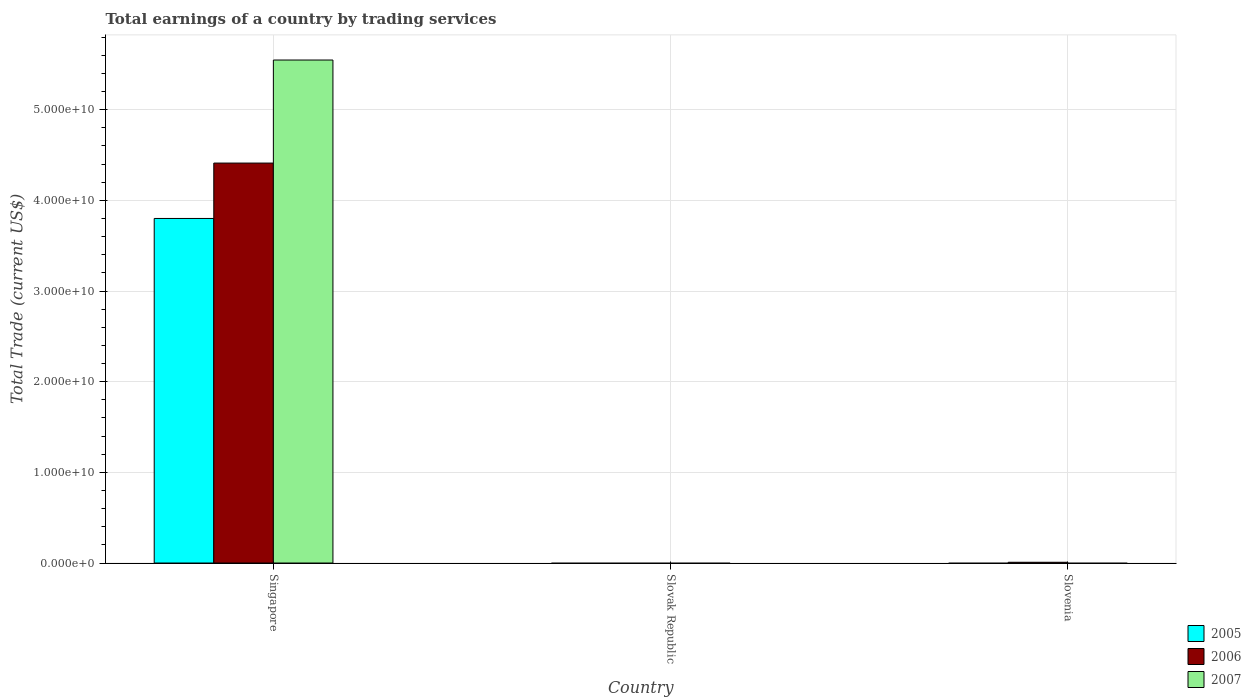Are the number of bars on each tick of the X-axis equal?
Your answer should be compact. No. How many bars are there on the 2nd tick from the left?
Give a very brief answer. 0. What is the label of the 2nd group of bars from the left?
Provide a succinct answer. Slovak Republic. What is the total earnings in 2006 in Singapore?
Your answer should be very brief. 4.41e+1. Across all countries, what is the maximum total earnings in 2006?
Provide a succinct answer. 4.41e+1. Across all countries, what is the minimum total earnings in 2005?
Your response must be concise. 0. In which country was the total earnings in 2007 maximum?
Your response must be concise. Singapore. What is the total total earnings in 2006 in the graph?
Provide a succinct answer. 4.42e+1. What is the difference between the total earnings in 2006 in Singapore and that in Slovenia?
Your answer should be compact. 4.40e+1. What is the difference between the total earnings in 2005 in Slovenia and the total earnings in 2006 in Slovak Republic?
Ensure brevity in your answer.  0. What is the average total earnings in 2006 per country?
Offer a terse response. 1.47e+1. What is the difference between the total earnings of/in 2007 and total earnings of/in 2005 in Singapore?
Provide a succinct answer. 1.75e+1. What is the ratio of the total earnings in 2006 in Singapore to that in Slovenia?
Your answer should be very brief. 526.53. What is the difference between the highest and the lowest total earnings in 2006?
Provide a short and direct response. 4.41e+1. Is it the case that in every country, the sum of the total earnings in 2007 and total earnings in 2005 is greater than the total earnings in 2006?
Keep it short and to the point. No. What is the difference between two consecutive major ticks on the Y-axis?
Your answer should be compact. 1.00e+1. Where does the legend appear in the graph?
Provide a succinct answer. Bottom right. What is the title of the graph?
Offer a very short reply. Total earnings of a country by trading services. What is the label or title of the Y-axis?
Provide a succinct answer. Total Trade (current US$). What is the Total Trade (current US$) of 2005 in Singapore?
Provide a short and direct response. 3.80e+1. What is the Total Trade (current US$) in 2006 in Singapore?
Provide a succinct answer. 4.41e+1. What is the Total Trade (current US$) of 2007 in Singapore?
Make the answer very short. 5.55e+1. What is the Total Trade (current US$) in 2005 in Slovenia?
Keep it short and to the point. 0. What is the Total Trade (current US$) in 2006 in Slovenia?
Make the answer very short. 8.38e+07. Across all countries, what is the maximum Total Trade (current US$) of 2005?
Your answer should be very brief. 3.80e+1. Across all countries, what is the maximum Total Trade (current US$) of 2006?
Your response must be concise. 4.41e+1. Across all countries, what is the maximum Total Trade (current US$) in 2007?
Make the answer very short. 5.55e+1. Across all countries, what is the minimum Total Trade (current US$) in 2005?
Provide a short and direct response. 0. Across all countries, what is the minimum Total Trade (current US$) in 2006?
Your answer should be compact. 0. Across all countries, what is the minimum Total Trade (current US$) in 2007?
Make the answer very short. 0. What is the total Total Trade (current US$) in 2005 in the graph?
Your response must be concise. 3.80e+1. What is the total Total Trade (current US$) of 2006 in the graph?
Your response must be concise. 4.42e+1. What is the total Total Trade (current US$) in 2007 in the graph?
Offer a terse response. 5.55e+1. What is the difference between the Total Trade (current US$) in 2006 in Singapore and that in Slovenia?
Your response must be concise. 4.40e+1. What is the difference between the Total Trade (current US$) of 2005 in Singapore and the Total Trade (current US$) of 2006 in Slovenia?
Your answer should be very brief. 3.79e+1. What is the average Total Trade (current US$) in 2005 per country?
Offer a terse response. 1.27e+1. What is the average Total Trade (current US$) of 2006 per country?
Provide a short and direct response. 1.47e+1. What is the average Total Trade (current US$) in 2007 per country?
Ensure brevity in your answer.  1.85e+1. What is the difference between the Total Trade (current US$) in 2005 and Total Trade (current US$) in 2006 in Singapore?
Provide a short and direct response. -6.11e+09. What is the difference between the Total Trade (current US$) of 2005 and Total Trade (current US$) of 2007 in Singapore?
Make the answer very short. -1.75e+1. What is the difference between the Total Trade (current US$) of 2006 and Total Trade (current US$) of 2007 in Singapore?
Your answer should be very brief. -1.14e+1. What is the ratio of the Total Trade (current US$) in 2006 in Singapore to that in Slovenia?
Your answer should be compact. 526.53. What is the difference between the highest and the lowest Total Trade (current US$) in 2005?
Offer a very short reply. 3.80e+1. What is the difference between the highest and the lowest Total Trade (current US$) of 2006?
Ensure brevity in your answer.  4.41e+1. What is the difference between the highest and the lowest Total Trade (current US$) of 2007?
Provide a succinct answer. 5.55e+1. 